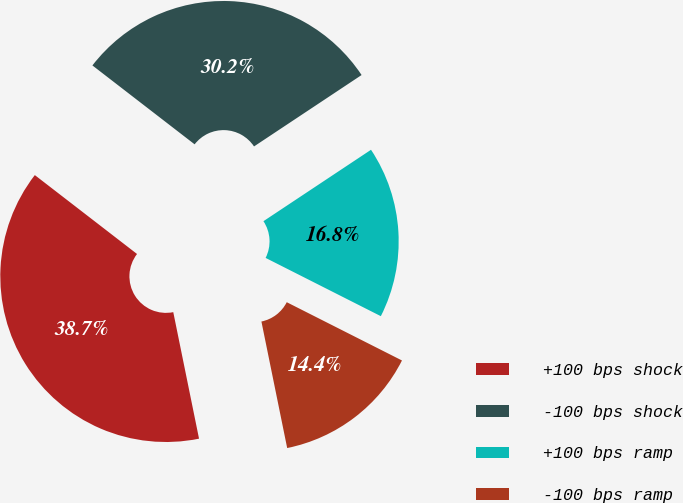Convert chart. <chart><loc_0><loc_0><loc_500><loc_500><pie_chart><fcel>+100 bps shock<fcel>-100 bps shock<fcel>+100 bps ramp<fcel>-100 bps ramp<nl><fcel>38.66%<fcel>30.21%<fcel>16.78%<fcel>14.35%<nl></chart> 